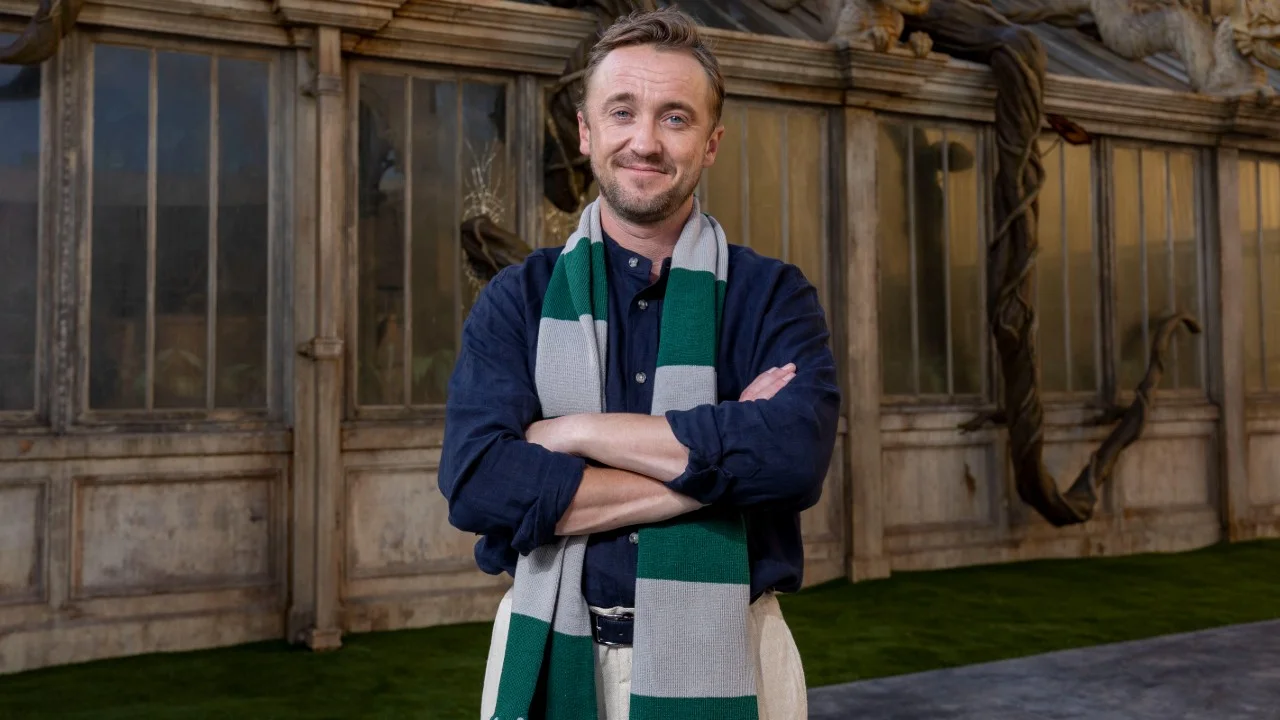How does the man's attire complement the surroundings in the image? The man's attire complements the surroundings by bridging a smart-casual look with a touch of academic or traditional style. His striped sweater and scarf resonate with a slightly scholarly look, while his jacket adds a layer of contemporary smartness. The combination fits well within the possibly historical or academic context provided by the gothic architecture in the background, suggesting a blend of modernity with traditional or classical elements. 